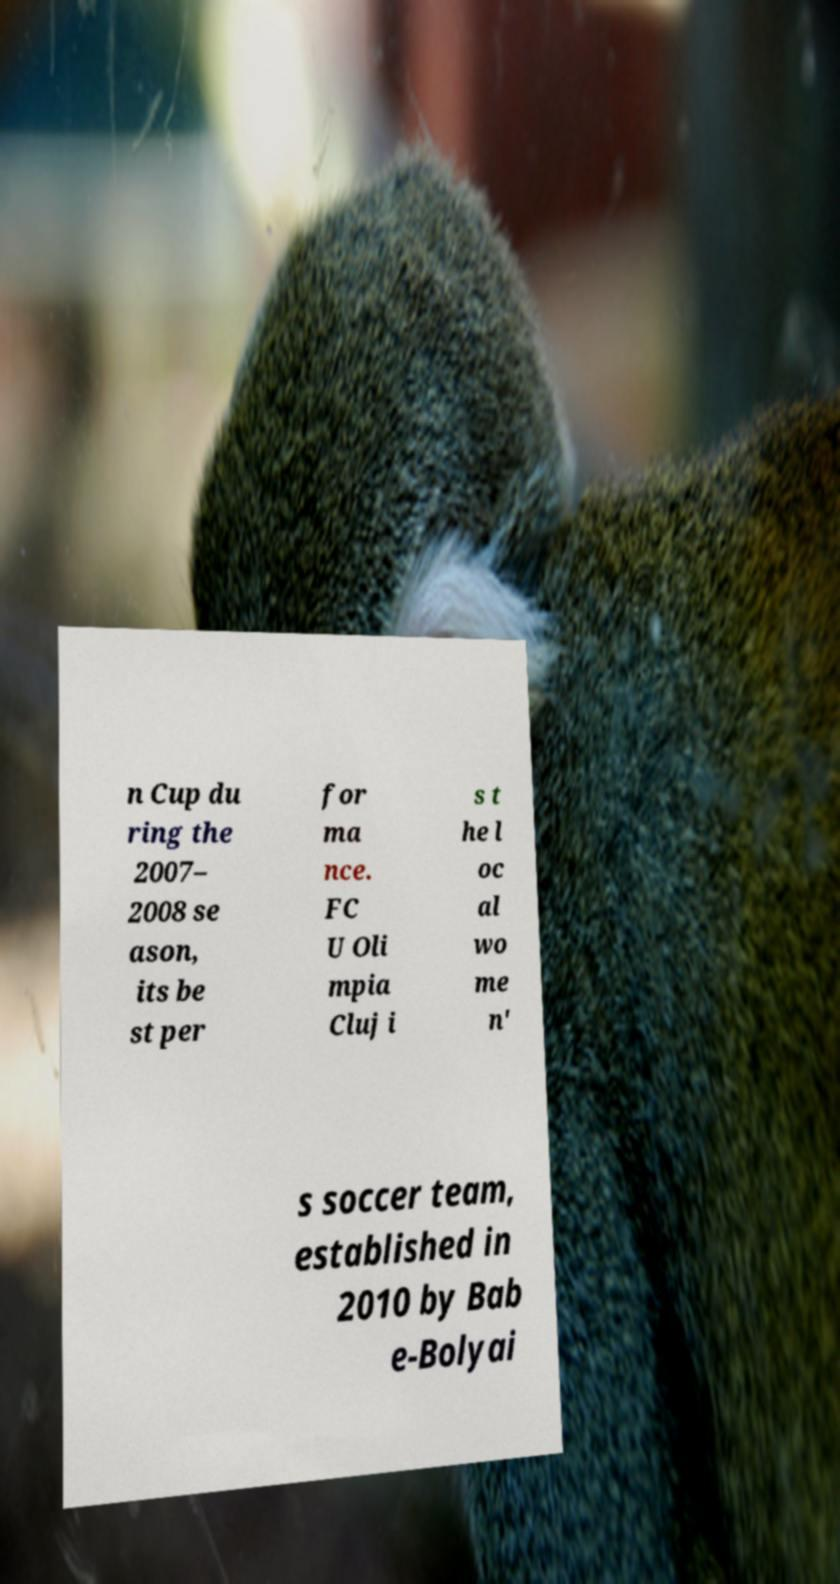There's text embedded in this image that I need extracted. Can you transcribe it verbatim? n Cup du ring the 2007– 2008 se ason, its be st per for ma nce. FC U Oli mpia Cluj i s t he l oc al wo me n' s soccer team, established in 2010 by Bab e-Bolyai 